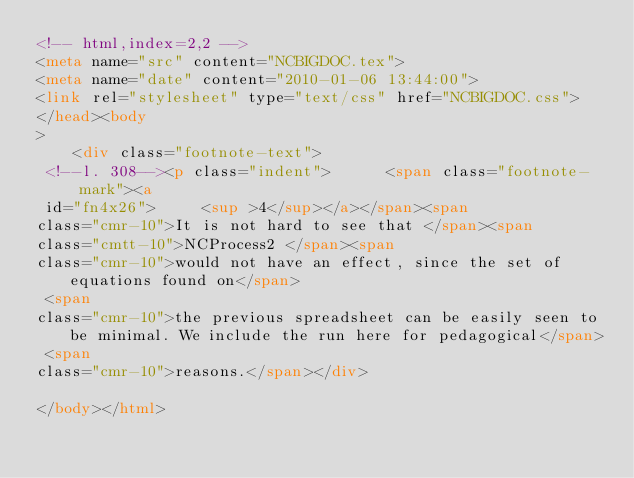<code> <loc_0><loc_0><loc_500><loc_500><_HTML_><!-- html,index=2,2 --> 
<meta name="src" content="NCBIGDOC.tex"> 
<meta name="date" content="2010-01-06 13:44:00"> 
<link rel="stylesheet" type="text/css" href="NCBIGDOC.css"> 
</head><body 
>
    <div class="footnote-text">
 <!--l. 308--><p class="indent">      <span class="footnote-mark"><a 
 id="fn4x26">     <sup >4</sup></a></span><span 
class="cmr-10">It is not hard to see that </span><span 
class="cmtt-10">NCProcess2 </span><span 
class="cmr-10">would not have an effect, since the set of equations found on</span>
 <span 
class="cmr-10">the previous spreadsheet can be easily seen to be minimal. We include the run here for pedagogical</span>
 <span 
class="cmr-10">reasons.</span></div>
    
</body></html> 
</code> 